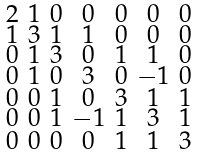<formula> <loc_0><loc_0><loc_500><loc_500>\begin{smallmatrix} 2 & 1 & 0 & 0 & 0 & 0 & 0 \\ 1 & 3 & 1 & 1 & 0 & 0 & 0 \\ 0 & 1 & 3 & 0 & 1 & 1 & 0 \\ 0 & 1 & 0 & 3 & 0 & - 1 & 0 \\ 0 & 0 & 1 & 0 & 3 & 1 & 1 \\ 0 & 0 & 1 & - 1 & 1 & 3 & 1 \\ 0 & 0 & 0 & 0 & 1 & 1 & 3 \end{smallmatrix}</formula> 